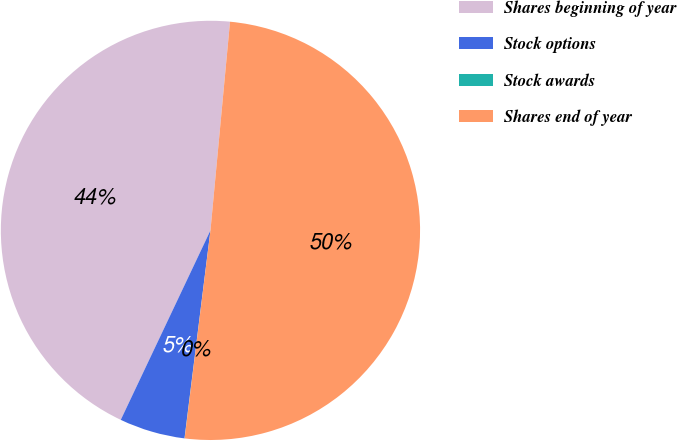Convert chart to OTSL. <chart><loc_0><loc_0><loc_500><loc_500><pie_chart><fcel>Shares beginning of year<fcel>Stock options<fcel>Stock awards<fcel>Shares end of year<nl><fcel>44.45%<fcel>5.06%<fcel>0.01%<fcel>50.48%<nl></chart> 